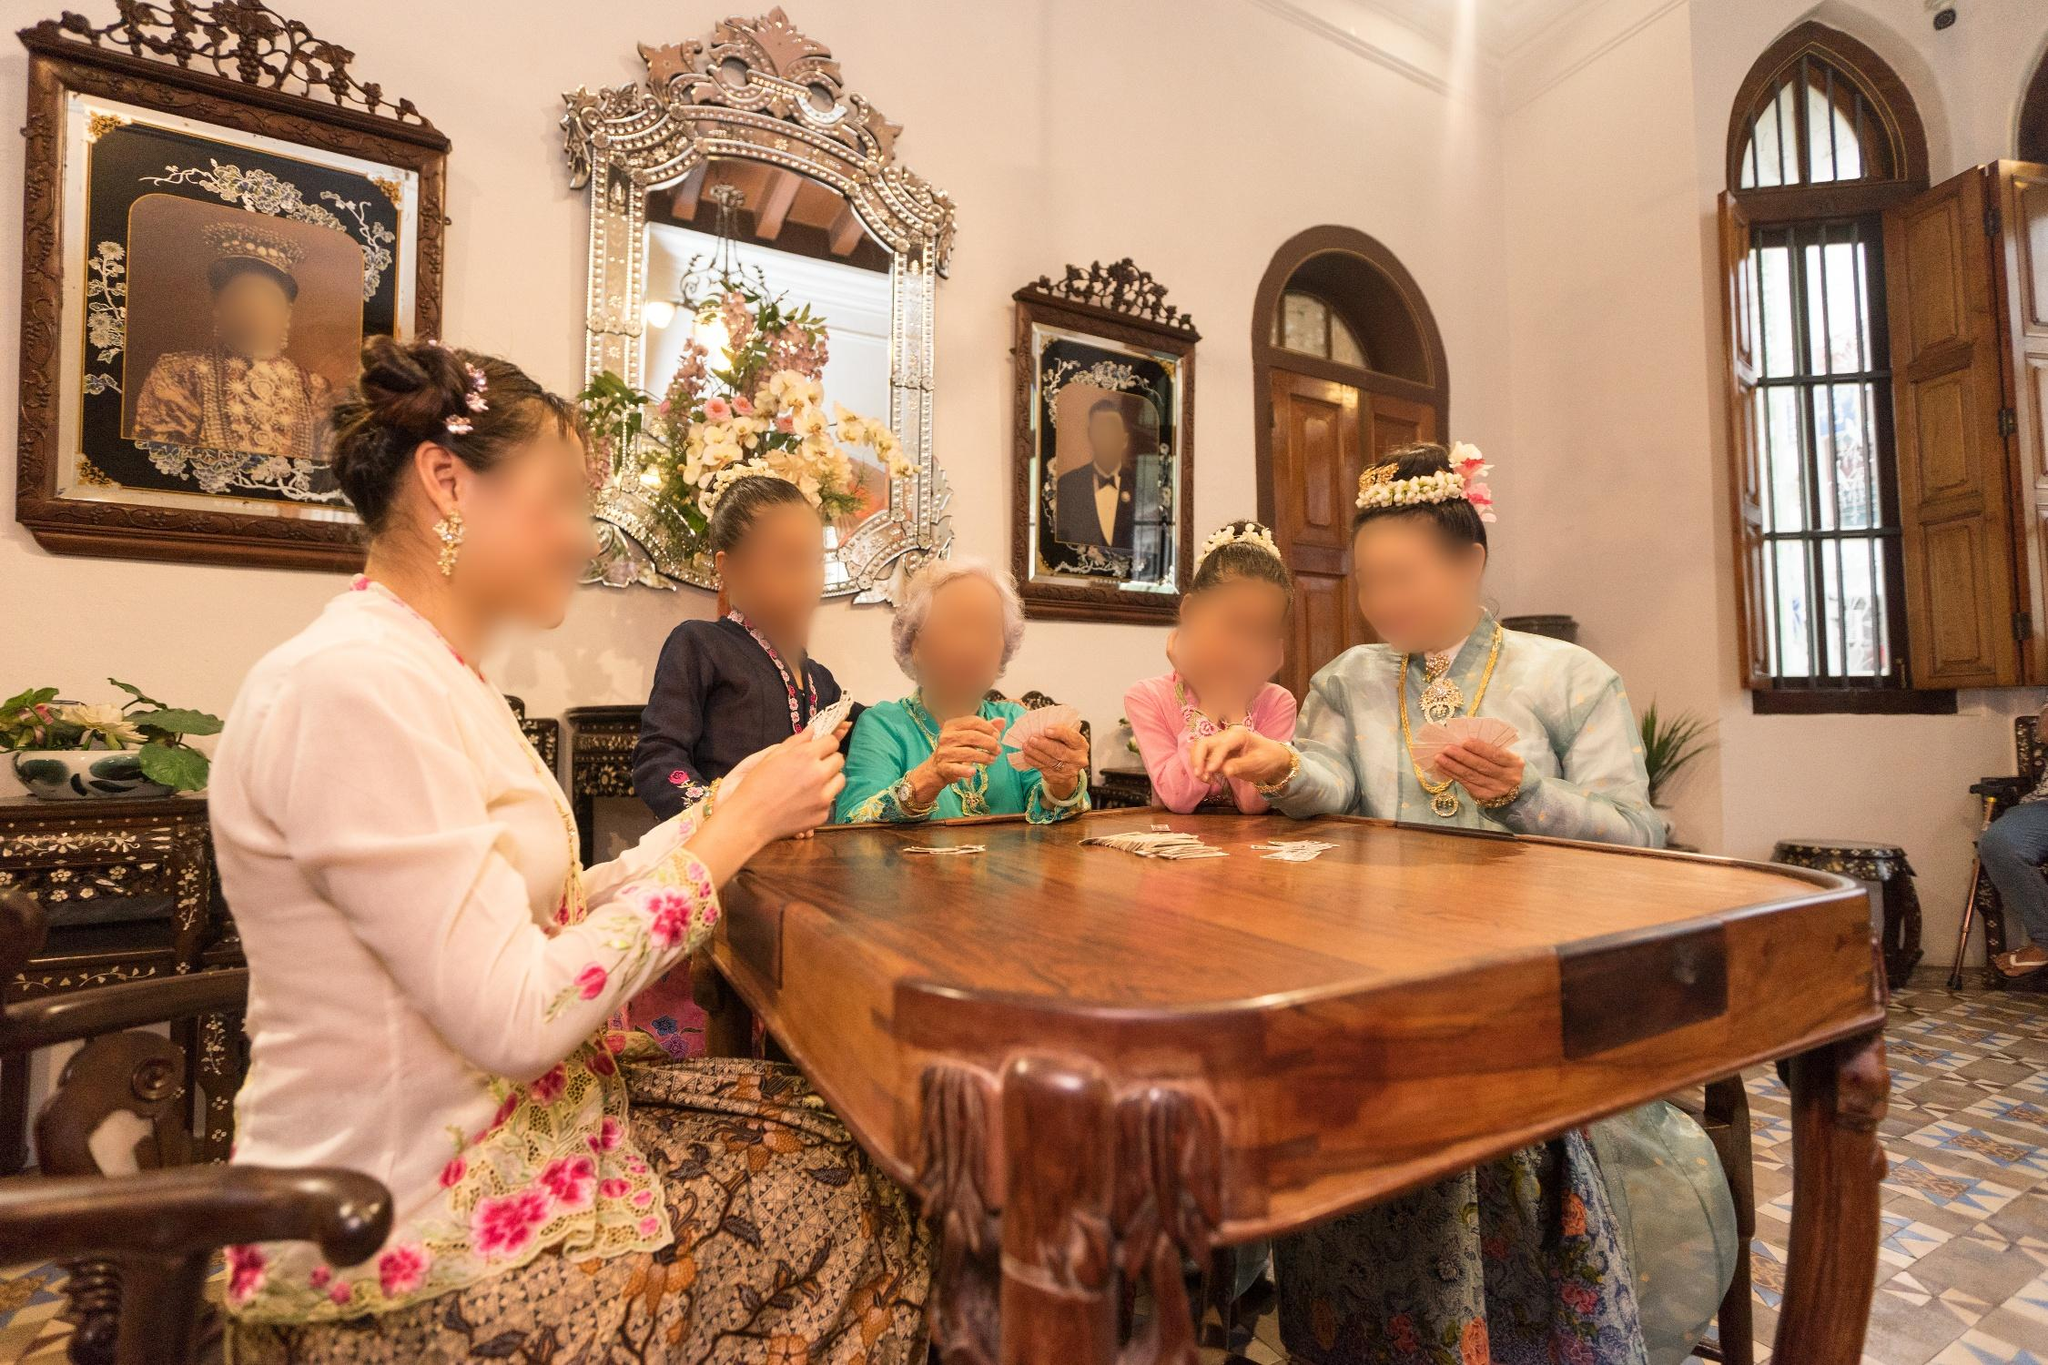What can you tell me about the age and style of the building seen in the image? The building exhibits features typical of historic colonial architecture, evident in the high ceilings, arched windows, and wooden casements. The interior is richly decorated with wood paneling and period furniture, which together with the decorative elements like the ornate mirror and classical portraits, point to the building's preservation and use as a heritage site, likely dating back at least a century. 